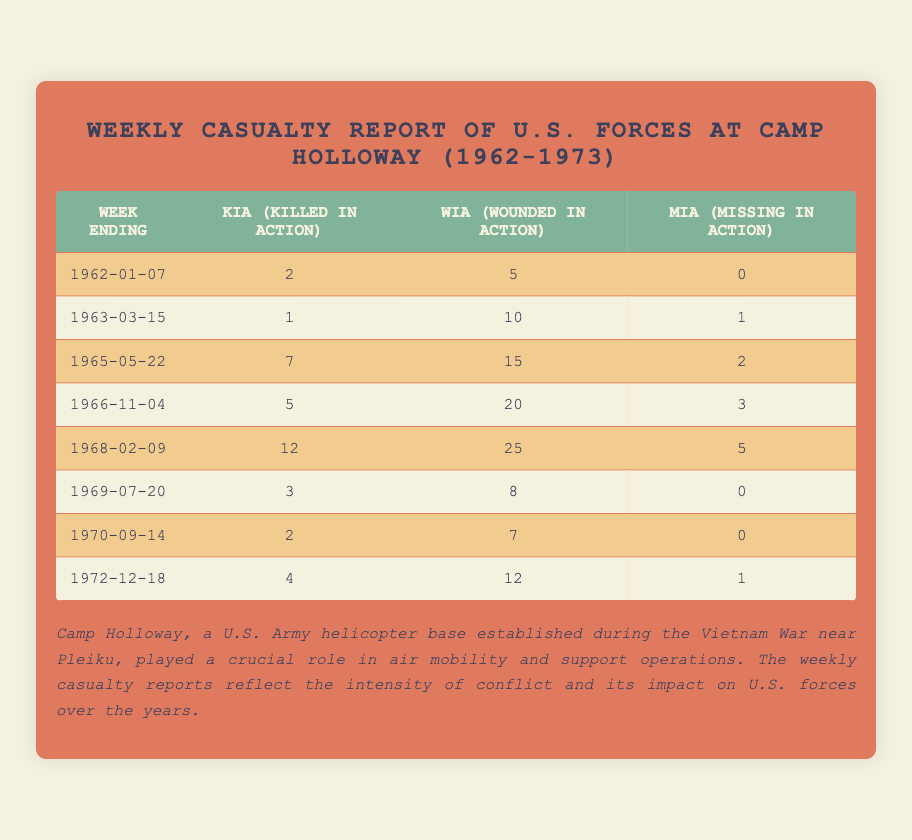what is the week ending for the highest KIA? The week ending for the highest KIA is identified by the maximum KIA count in the table, which is 12 on the week ending February 9, 1968.
Answer: 1968-02-09 how many WIA were reported in the week ending March 15, 1963? The number of WIA reported in this specific week, as shown in the table, is indicated in the corresponding row for that date.
Answer: 10 what was the total number of MIA over the listed weeks? The total MIA is the sum of all MIA values from each week provided in the table, calculated as 0 + 1 + 2 + 3 + 5 + 0 + 0 + 1 = 12.
Answer: 12 which week had the lowest KIA? The lowest KIA is determined by comparing the KIA values across the weeks in the table, which is 1 on the week ending March 15, 1963.
Answer: 1963-03-15 how many total casualties (KIA + WIA + MIA) were reported in the week ending November 4, 1966? Total casualties for that week can be found by adding KIA, WIA, and MIA together according to the data for that week.
Answer: 28 what pattern is observed in the WIA over time? By examining the WIA counts over the weeks, we see that they tend to fluctuate, showing an increase and then a decrease, indicating variability in conflict intensity.
Answer: Fluctuating what is the significance of Camp Holloway during the Vietnam War? The significance is detailed in the notes, highlighting its role during the Vietnam conflict, especially regarding U.S. military operations.
Answer: Air mobility and support operations how many weeks show no MIA? The count of weeks with zero MIA can be found by examining the values in the MIA column of the table.
Answer: 4 